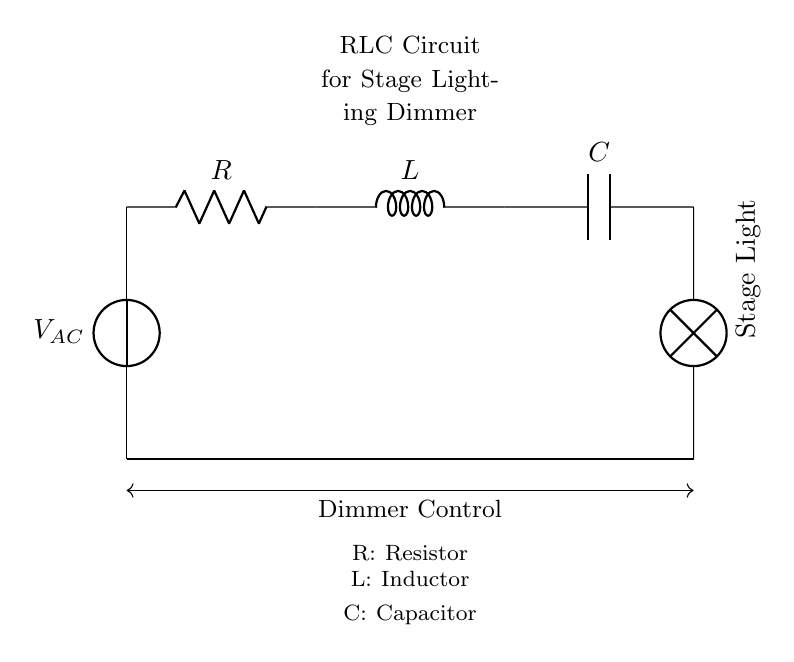What is the primary function of the RLC circuit in this diagram? The RLC circuit is used for controlling the dimming of stage lights. It consists of a resistor, inductor, and capacitor which work together to manage the voltage and current in the lighting system.
Answer: stage lighting dimmer What is the voltage source indicated in the circuit? The circuit has one voltage source, labeled as V AC, which stands for alternating current voltage. It provides the necessary electrical energy for the circuit to operate.
Answer: V AC Identify the component labeled as "C" in the circuit. The component labeled "C" is a capacitor. Capacitors store and discharge electrical energy, helping to regulate the current flow in the circuit.
Answer: capacitor How many main components are in the RLC circuit? The circuit features three main components: a resistor, an inductor, and a capacitor, which are critical for its operation in controlling lighting brightness.
Answer: three Explain the role of the inductor in this circuit. The inductor, labeled "L," resists changes in current, helping to smooth out the flow in the dimmer system. It works in conjunction with the resistor and capacitor to shape the electrical signals used for dimming the lights.
Answer: smooth current flow What is the orientation of the stage light in the circuit? The stage light is oriented vertically, as indicated by the rotation of the label. This orientation mimics real-life placement of stage lights in theatre setups.
Answer: vertical What type of connection is used to complete the circuit back to the voltage source? The circuit completes the connection with a direct line from the stage light back to the voltage source, forming a closed loop essential for current flow.
Answer: closed loop 